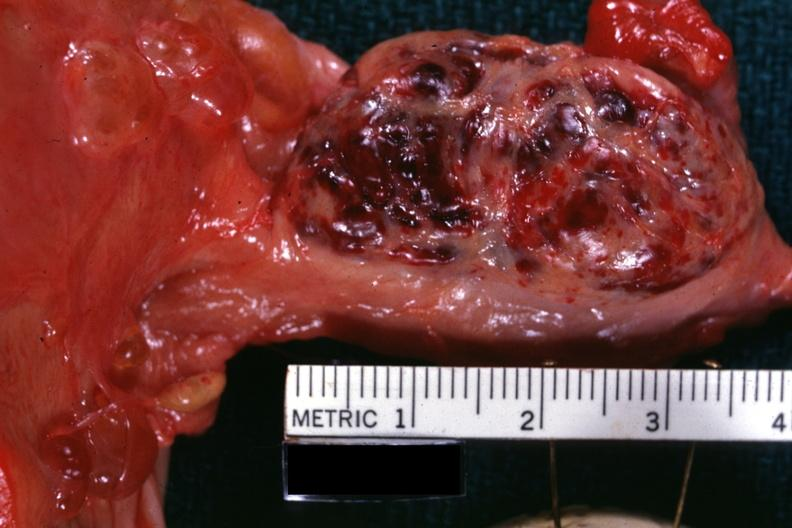does omentum show close-up external view of hemorrhagic mass?
Answer the question using a single word or phrase. No 